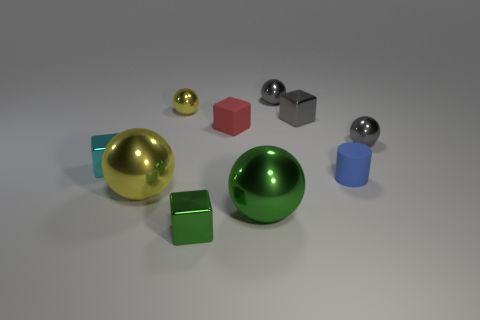Are there any other things that are the same shape as the blue rubber object?
Offer a very short reply. No. What number of tiny red cylinders are there?
Your response must be concise. 0. Are there any yellow shiny objects that have the same size as the blue cylinder?
Offer a terse response. Yes. Do the small red object and the small gray ball left of the small gray metallic block have the same material?
Make the answer very short. No. There is a red object that is behind the tiny blue rubber thing; what is it made of?
Your answer should be very brief. Rubber. What size is the green metal sphere?
Provide a succinct answer. Large. There is a yellow ball that is behind the red thing; does it have the same size as the shiny block that is in front of the cyan cube?
Provide a succinct answer. Yes. The green metallic object that is the same shape as the tiny yellow metal object is what size?
Ensure brevity in your answer.  Large. Do the blue rubber cylinder and the gray sphere on the left side of the blue cylinder have the same size?
Keep it short and to the point. Yes. There is a small gray shiny sphere in front of the small gray metal block; are there any gray metal spheres that are on the left side of it?
Ensure brevity in your answer.  Yes. 